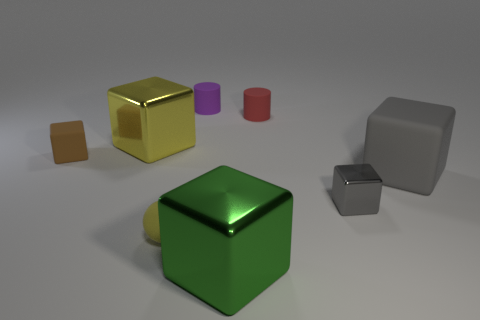Subtract all purple blocks. Subtract all yellow cylinders. How many blocks are left? 5 Add 1 rubber things. How many objects exist? 9 Subtract all cylinders. How many objects are left? 6 Add 2 large shiny blocks. How many large shiny blocks are left? 4 Add 3 large purple cylinders. How many large purple cylinders exist? 3 Subtract 0 red balls. How many objects are left? 8 Subtract all small balls. Subtract all matte balls. How many objects are left? 6 